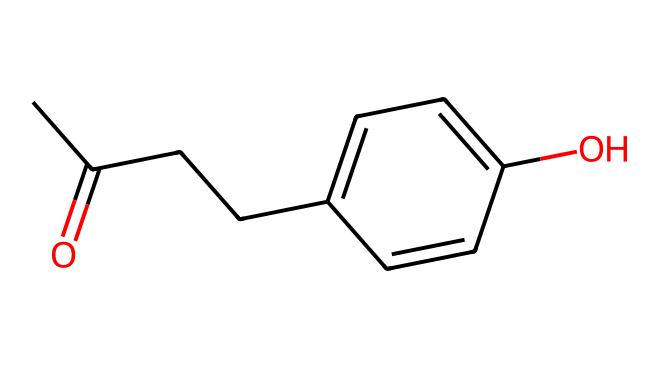What is the functional group present in raspberry ketone? The structure contains a carbonyl group (C=O) attached to a carbon atom, identifying it as a ketone.
Answer: carbonyl group How many carbon atoms are in raspberry ketone? By counting the carbon atoms in the SMILES representation, I find there are nine carbon atoms total in the compound.
Answer: nine What type of chemical is raspberry ketone classified as? Raspberry ketone is a type of aromatic compound because it contains a benzene ring in its structure.
Answer: aromatic compound What is the total number of hydroxyl groups in raspberry ketone? The hydroxyl group (–OH) is present in the structure, and there is only one of them in raspberry ketone.
Answer: one How many double bonds are present in raspberry ketone? Observing the structure, there are two double bonds: one in the carbonyl group and one in the benzene ring, totaling two.
Answer: two What does the presence of the carbonyl group suggest about raspberry ketone? The presence of the carbonyl group indicates that raspberry ketone is capable of participating in reactions typical of ketones, such as forming hydrates or reacting with alcohols.
Answer: capability to react Which part of the structure contributes to the aroma of raspberries? The aromatic part, which is the benzene ring in the structure, contributes specifically to the fruity aroma characteristic of raspberries.
Answer: benzene ring 